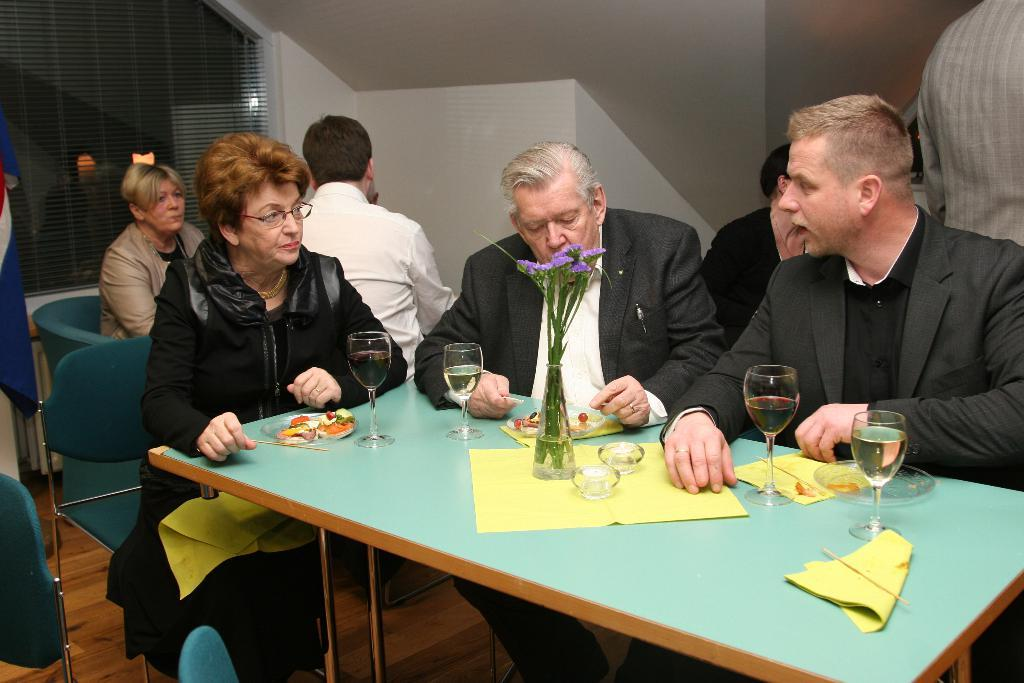What are the people in the image doing? The people in the image are sitting on chairs. What is present in the image besides the people? There is a table in the image. What can be found on the table? There is a plant, glasses, and a cloth on the table. Where is the dock located in the image? There is no dock present in the image. What type of sail is on the plant in the image? There is no sail present in the image, as it features a plant on a table. 